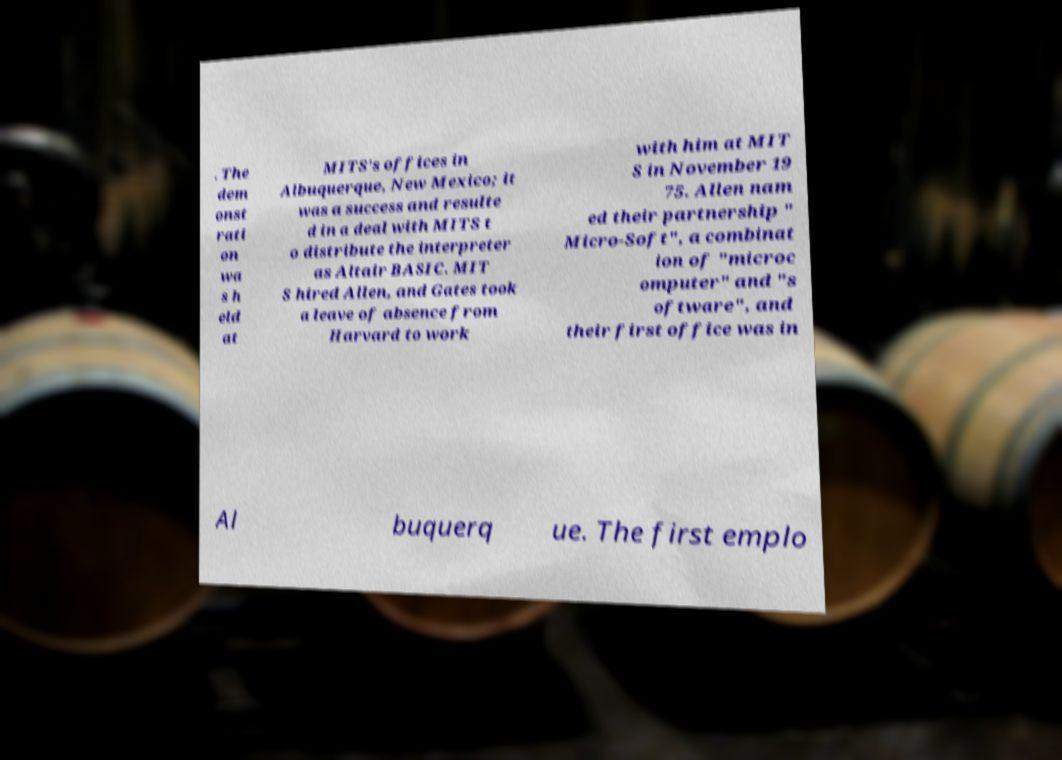There's text embedded in this image that I need extracted. Can you transcribe it verbatim? . The dem onst rati on wa s h eld at MITS's offices in Albuquerque, New Mexico; it was a success and resulte d in a deal with MITS t o distribute the interpreter as Altair BASIC. MIT S hired Allen, and Gates took a leave of absence from Harvard to work with him at MIT S in November 19 75. Allen nam ed their partnership " Micro-Soft", a combinat ion of "microc omputer" and "s oftware", and their first office was in Al buquerq ue. The first emplo 